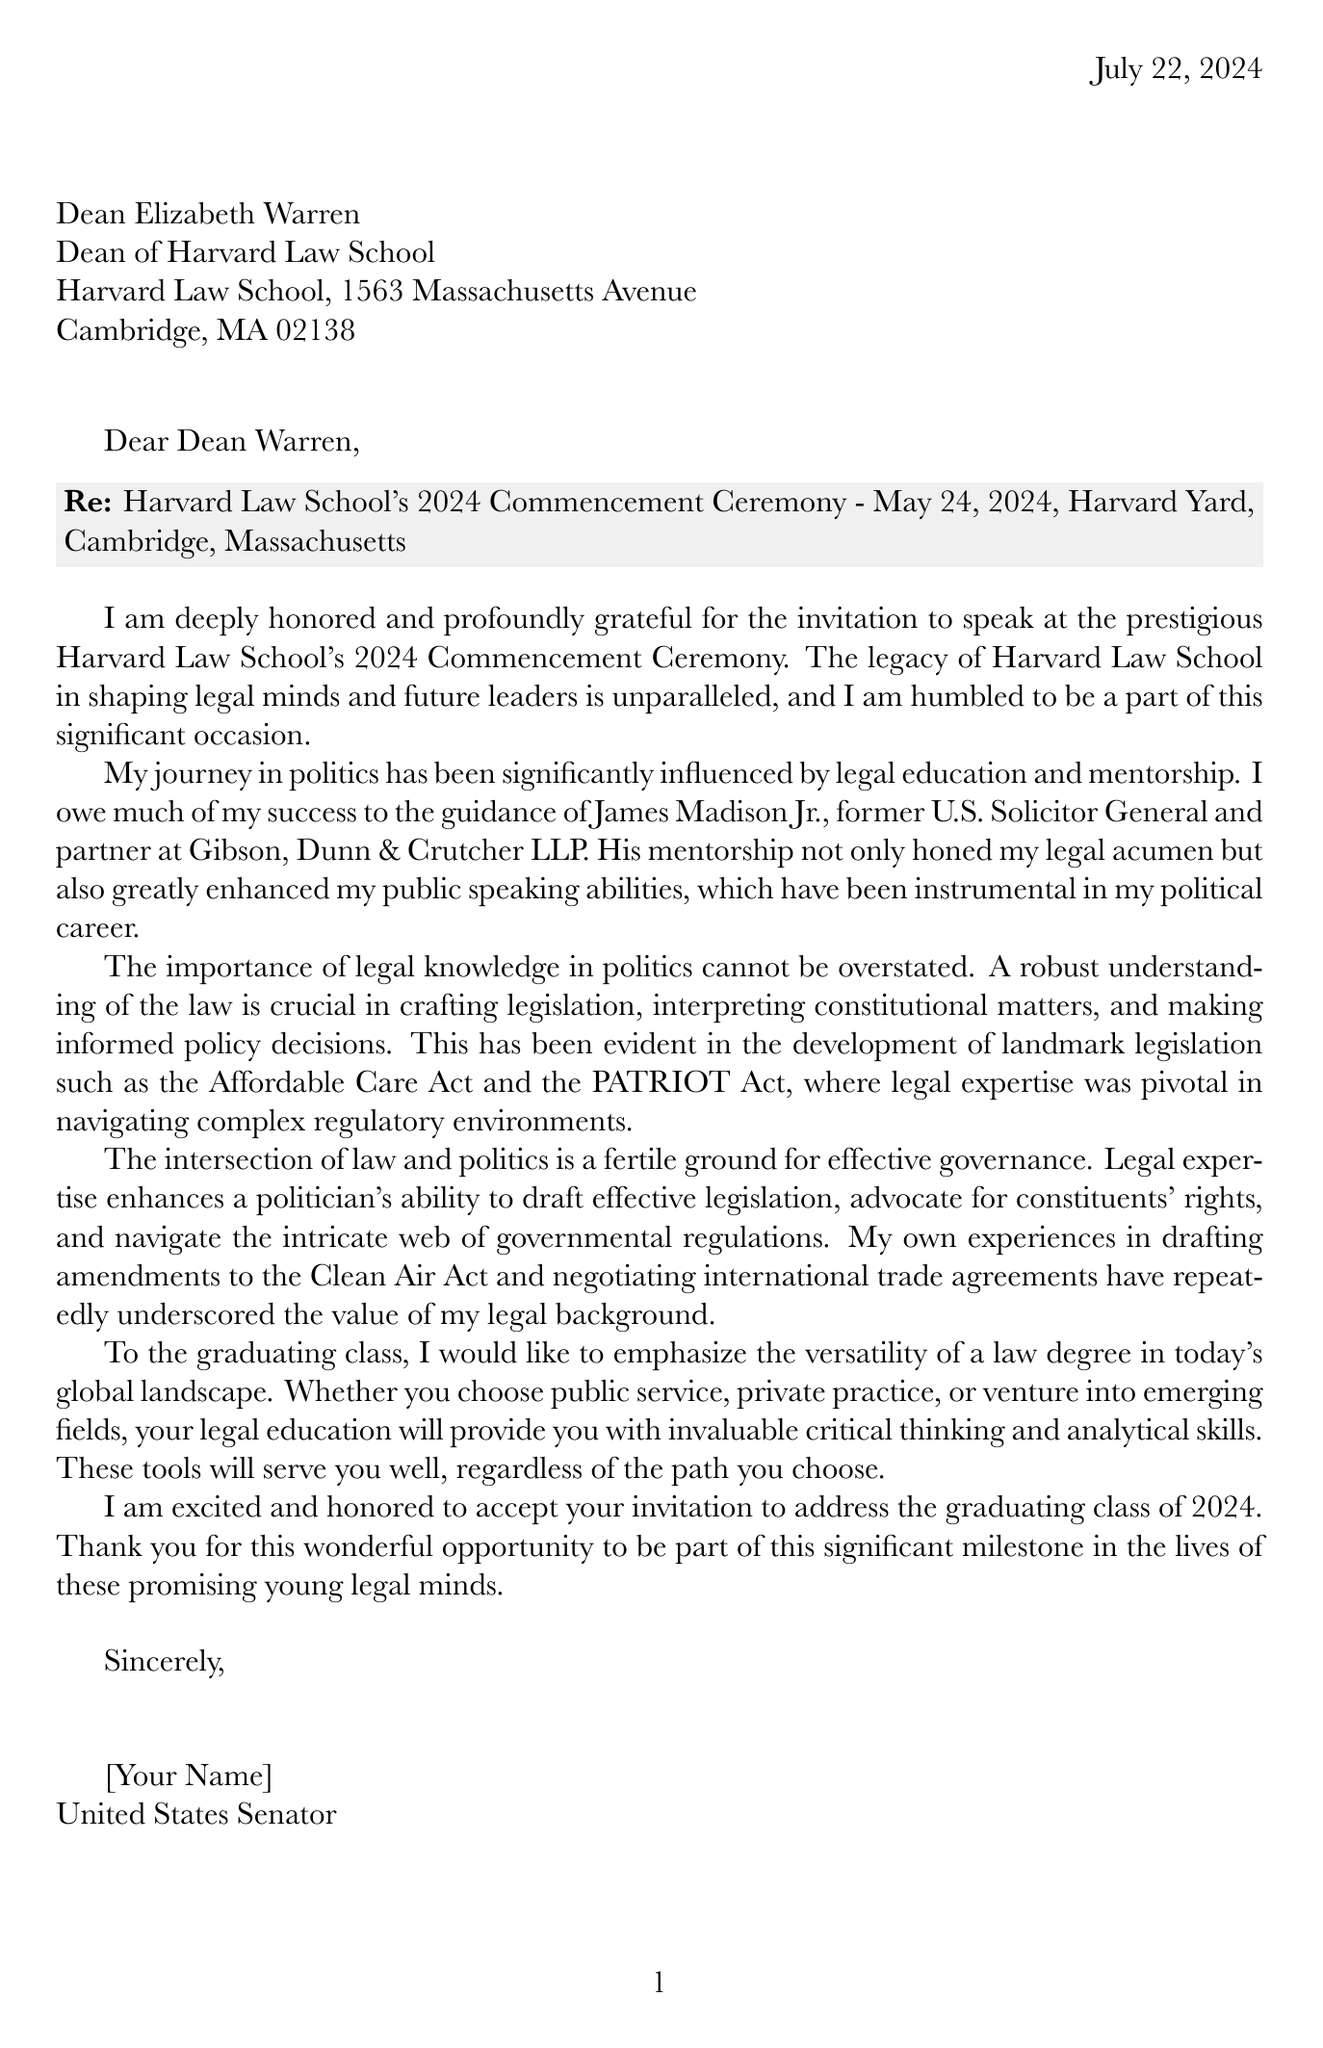What is the recipient's name? The recipient's name is explicitly mentioned in the header of the document as Dean Elizabeth Warren.
Answer: Dean Elizabeth Warren What is the date of the commencement ceremony? The document specifies the date of the event in the introduction section, which is May 24, 2024.
Answer: May 24, 2024 Who mentored the writer? The letter mentions that the writer was mentored by James Madison Jr., outlining his credentials in the document.
Answer: James Madison Jr What is the significance of legal knowledge in politics according to the document? The body paragraph outlines that legal knowledge is crucial for crafting legislation and making informed policy decisions, illustrated by examples from legislation such as the Affordable Care Act.
Answer: Crucial role What type of degree does the letter emphasize as versatile? The writer advises the graduates that a law degree is versatile for various career paths, indicating the value of legal education in diverse fields.
Answer: Law degree What is the conclusion of the letter regarding the invitation? The conclusion expresses acceptance of the invitation and excitement about addressing the graduates, confirming the writer's enthusiasm for the event.
Answer: Acceptance and excitement How many terms has the writer served in the U.S. Senate? The document lists the writer’s personal achievements, including serving three terms in the U.S. Senate.
Answer: Three terms What is the specific location of the commencement ceremony? The letter states that the commencement ceremony will be held at Harvard Yard, Cambridge, Massachusetts.
Answer: Harvard Yard, Cambridge, Massachusetts 